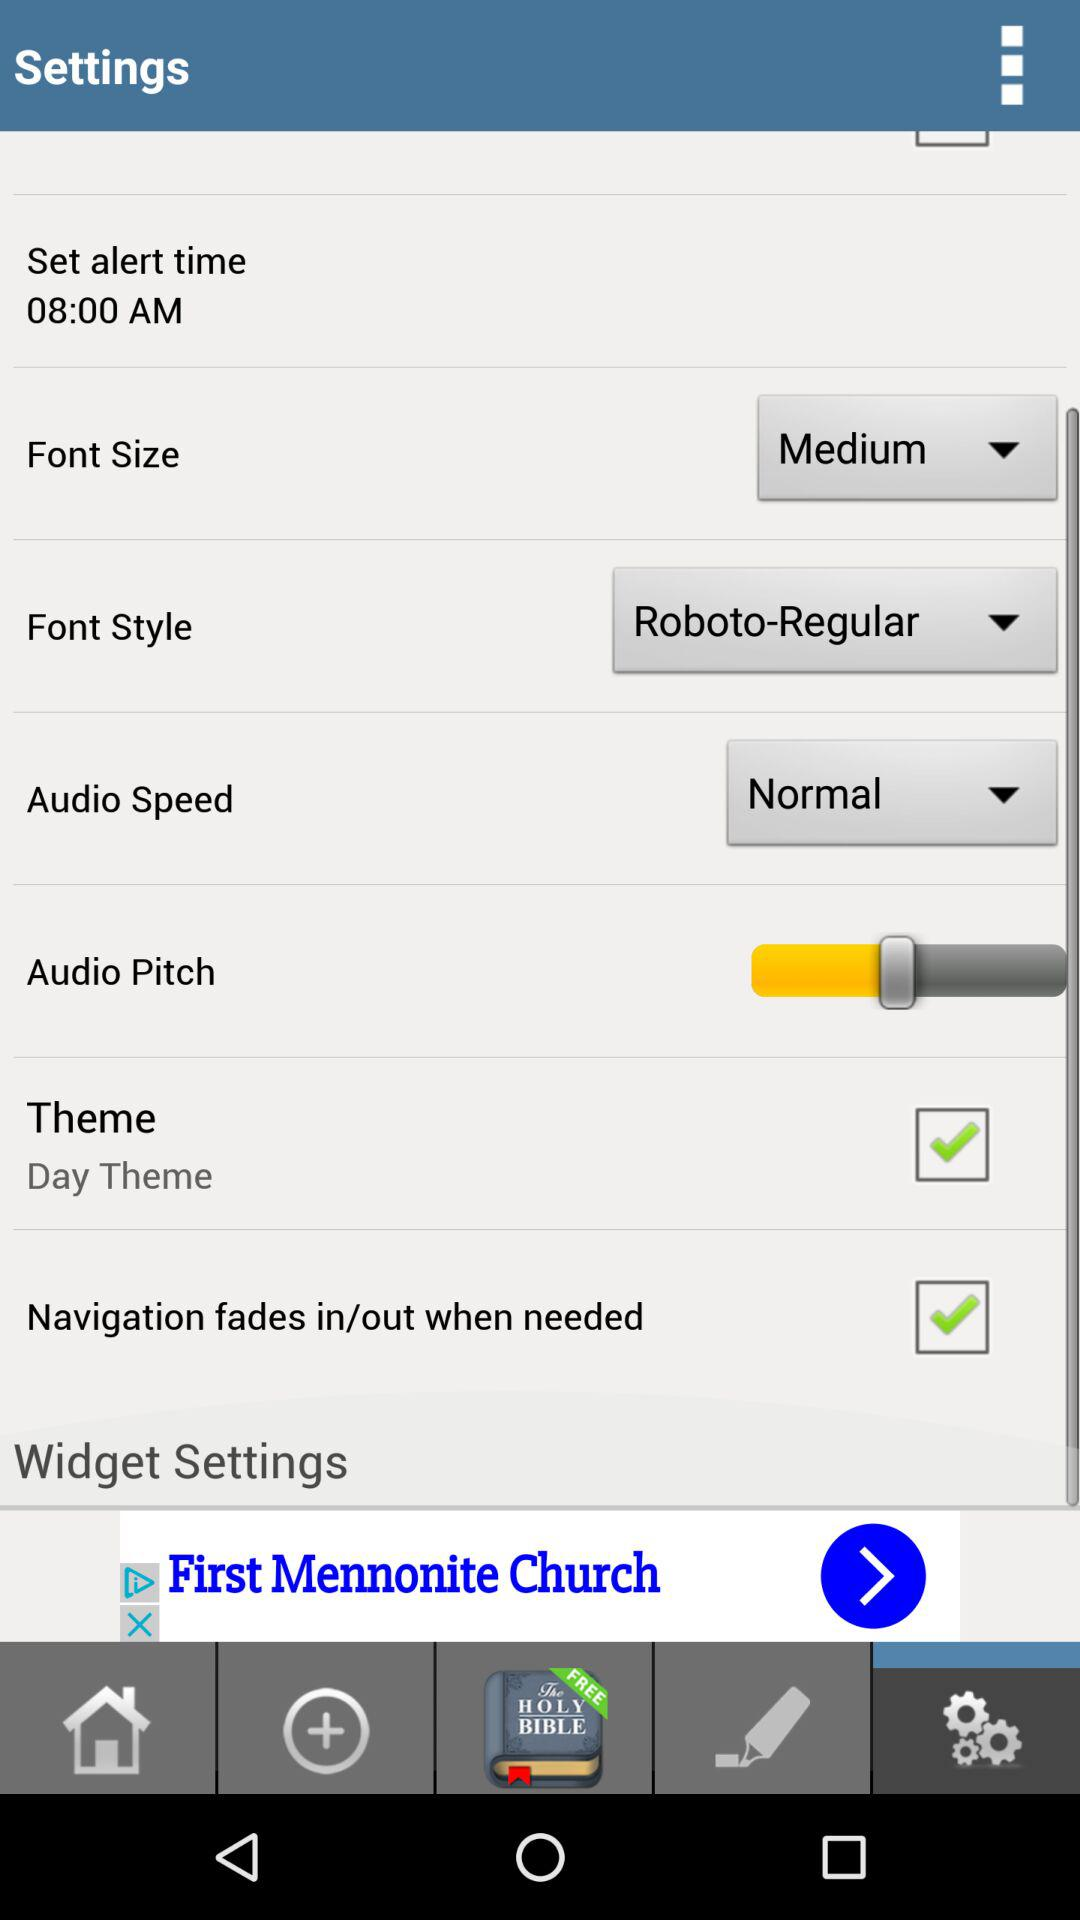Which audio speed is selected? The selected audio speed is "Normal". 